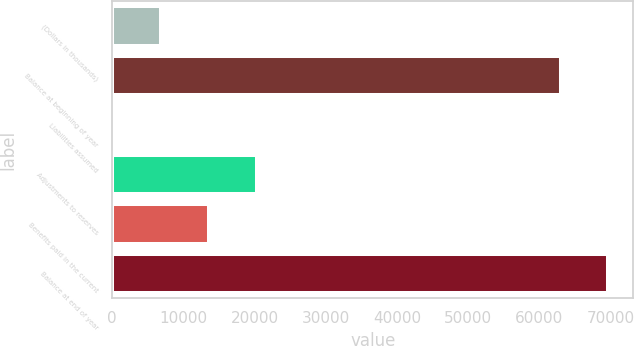Convert chart to OTSL. <chart><loc_0><loc_0><loc_500><loc_500><bar_chart><fcel>(Dollars in thousands)<fcel>Balance at beginning of year<fcel>Liabilities assumed<fcel>Adjustments to reserves<fcel>Benefits paid in the current<fcel>Balance at end of year<nl><fcel>6877.1<fcel>63002<fcel>176<fcel>20279.3<fcel>13578.2<fcel>69703.1<nl></chart> 